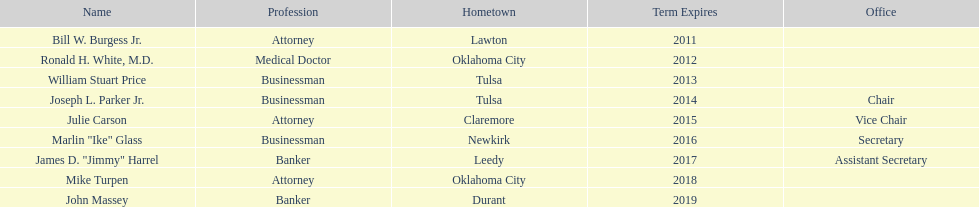What is the total number of state regents who are attorneys? 3. 